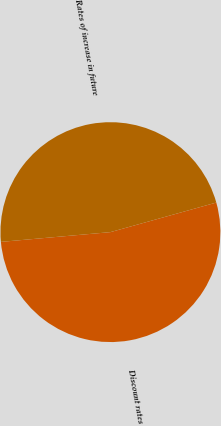Convert chart to OTSL. <chart><loc_0><loc_0><loc_500><loc_500><pie_chart><fcel>Discount rates<fcel>Rates of increase in future<nl><fcel>52.92%<fcel>47.08%<nl></chart> 